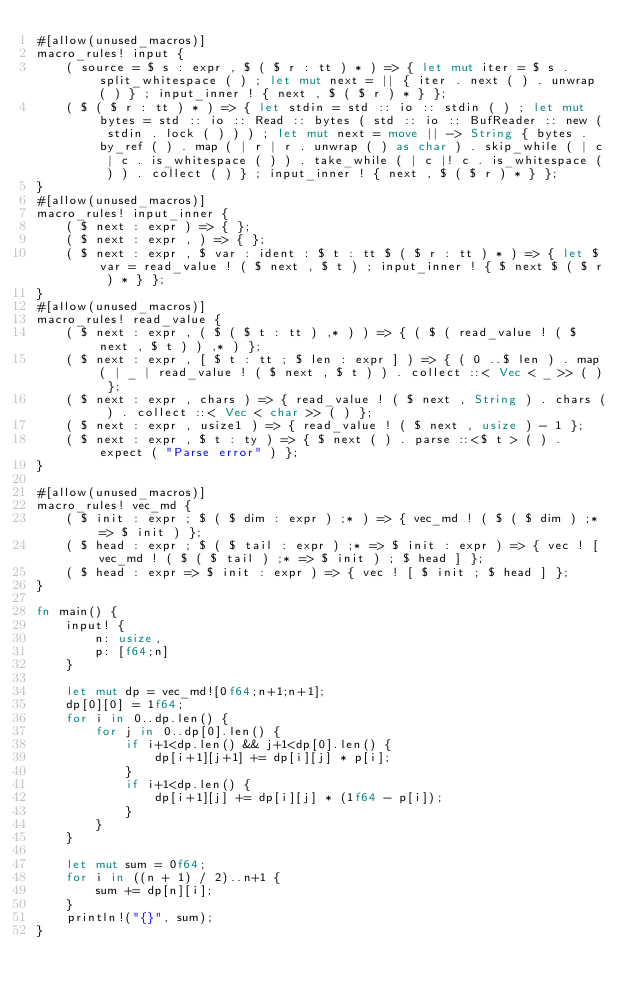Convert code to text. <code><loc_0><loc_0><loc_500><loc_500><_Rust_>#[allow(unused_macros)]
macro_rules! input {
    ( source = $ s : expr , $ ( $ r : tt ) * ) => { let mut iter = $ s . split_whitespace ( ) ; let mut next = || { iter . next ( ) . unwrap ( ) } ; input_inner ! { next , $ ( $ r ) * } };
    ( $ ( $ r : tt ) * ) => { let stdin = std :: io :: stdin ( ) ; let mut bytes = std :: io :: Read :: bytes ( std :: io :: BufReader :: new ( stdin . lock ( ) ) ) ; let mut next = move || -> String { bytes . by_ref ( ) . map ( | r | r . unwrap ( ) as char ) . skip_while ( | c | c . is_whitespace ( ) ) . take_while ( | c |! c . is_whitespace ( ) ) . collect ( ) } ; input_inner ! { next , $ ( $ r ) * } };
}
#[allow(unused_macros)]
macro_rules! input_inner {
    ( $ next : expr ) => { };
    ( $ next : expr , ) => { };
    ( $ next : expr , $ var : ident : $ t : tt $ ( $ r : tt ) * ) => { let $ var = read_value ! ( $ next , $ t ) ; input_inner ! { $ next $ ( $ r ) * } };
}
#[allow(unused_macros)]
macro_rules! read_value {
    ( $ next : expr , ( $ ( $ t : tt ) ,* ) ) => { ( $ ( read_value ! ( $ next , $ t ) ) ,* ) };
    ( $ next : expr , [ $ t : tt ; $ len : expr ] ) => { ( 0 ..$ len ) . map ( | _ | read_value ! ( $ next , $ t ) ) . collect ::< Vec < _ >> ( ) };
    ( $ next : expr , chars ) => { read_value ! ( $ next , String ) . chars ( ) . collect ::< Vec < char >> ( ) };
    ( $ next : expr , usize1 ) => { read_value ! ( $ next , usize ) - 1 };
    ( $ next : expr , $ t : ty ) => { $ next ( ) . parse ::<$ t > ( ) . expect ( "Parse error" ) };
}

#[allow(unused_macros)]
macro_rules! vec_md {
    ( $ init : expr ; $ ( $ dim : expr ) ;* ) => { vec_md ! ( $ ( $ dim ) ;* => $ init ) };
    ( $ head : expr ; $ ( $ tail : expr ) ;* => $ init : expr ) => { vec ! [ vec_md ! ( $ ( $ tail ) ;* => $ init ) ; $ head ] };
    ( $ head : expr => $ init : expr ) => { vec ! [ $ init ; $ head ] };
}

fn main() {
    input! {
        n: usize,
        p: [f64;n]
    }

    let mut dp = vec_md![0f64;n+1;n+1];
    dp[0][0] = 1f64;
    for i in 0..dp.len() {
        for j in 0..dp[0].len() {
            if i+1<dp.len() && j+1<dp[0].len() {
                dp[i+1][j+1] += dp[i][j] * p[i];
            }
            if i+1<dp.len() {
                dp[i+1][j] += dp[i][j] * (1f64 - p[i]);
            }
        }
    }

    let mut sum = 0f64;
    for i in ((n + 1) / 2)..n+1 {
        sum += dp[n][i];
    }
    println!("{}", sum);
}</code> 